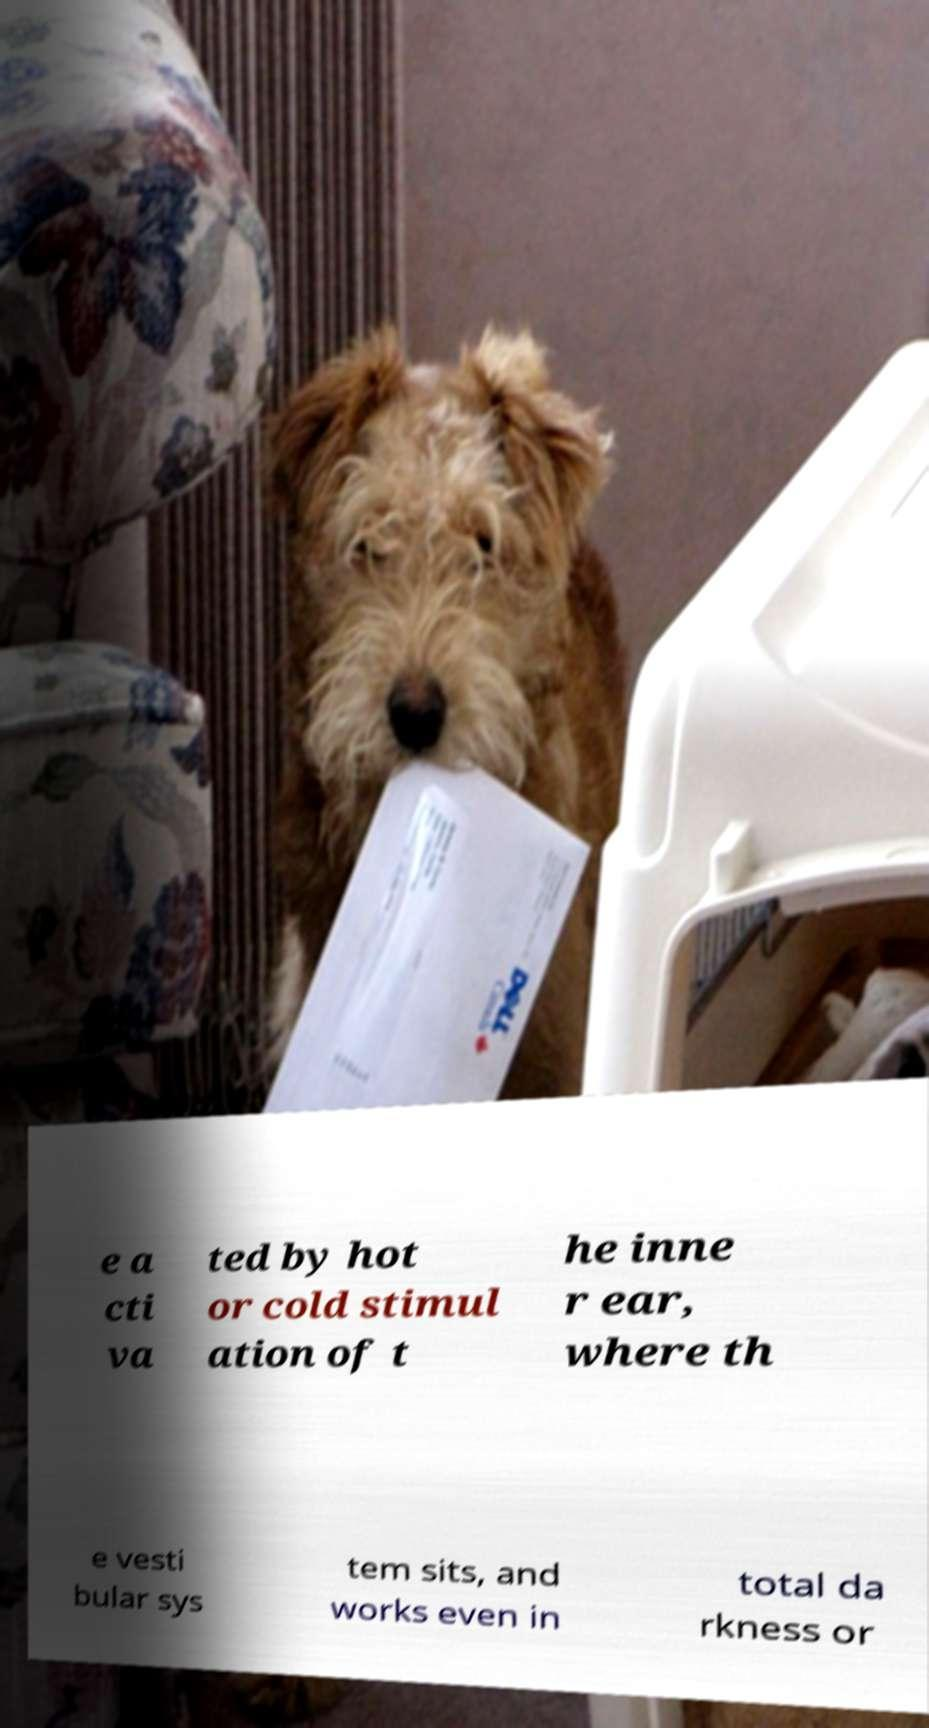Can you accurately transcribe the text from the provided image for me? e a cti va ted by hot or cold stimul ation of t he inne r ear, where th e vesti bular sys tem sits, and works even in total da rkness or 